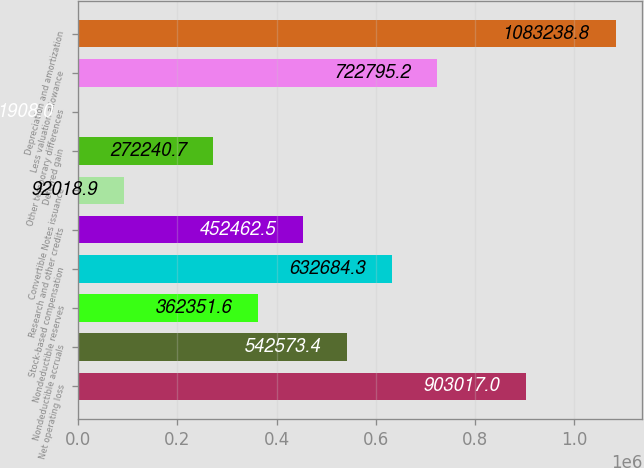Convert chart. <chart><loc_0><loc_0><loc_500><loc_500><bar_chart><fcel>Net operating loss<fcel>Nondeductible accruals<fcel>Nondeductible reserves<fcel>Stock-based compensation<fcel>Research and other credits<fcel>Convertible Notes issuance<fcel>Deferred gain<fcel>Other temporary differences<fcel>Less valuation allowance<fcel>Depreciation and amortization<nl><fcel>903017<fcel>542573<fcel>362352<fcel>632684<fcel>452462<fcel>92018.9<fcel>272241<fcel>1908<fcel>722795<fcel>1.08324e+06<nl></chart> 